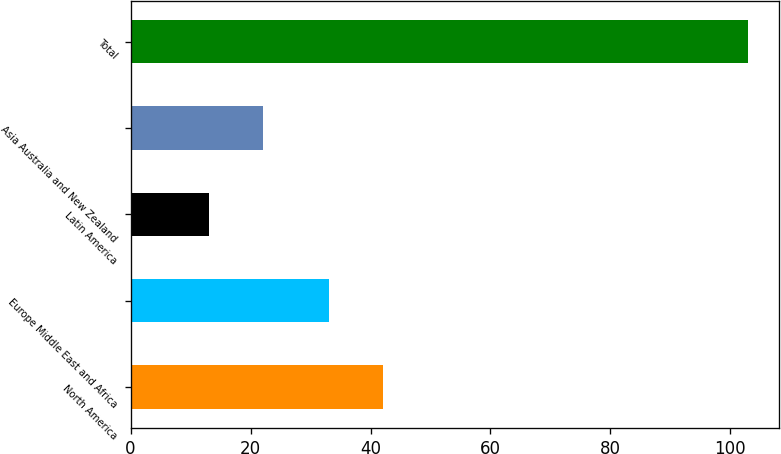<chart> <loc_0><loc_0><loc_500><loc_500><bar_chart><fcel>North America<fcel>Europe Middle East and Africa<fcel>Latin America<fcel>Asia Australia and New Zealand<fcel>Total<nl><fcel>42<fcel>33<fcel>13<fcel>22<fcel>103<nl></chart> 